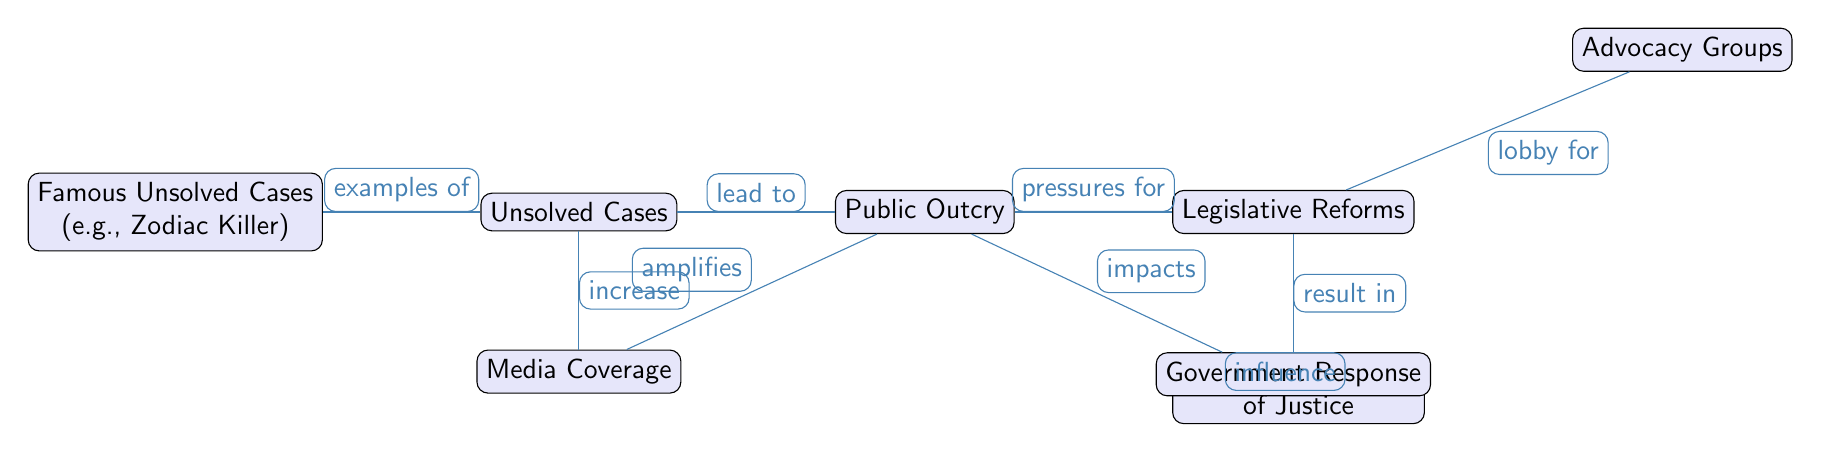What is the first node in the diagram? The first node in the diagram is labeled "Unsolved Cases," as it is positioned at the topmost part of the flow.
Answer: Unsolved Cases How many nodes are present in the diagram? By counting each of the distinct labeled boxes in the diagram, we find there are a total of eight nodes, including "Unsolved Cases" and "Legislative Reforms."
Answer: 8 What does "Public Outcry" lead to? The diagram shows that "Public Outcry" connects to and impacts "Societal Perceptions of Justice," as indicated by the directed edge between those two nodes.
Answer: Societal Perceptions of Justice Which node provides examples of "Unsolved Cases"? The node labeled "Famous Unsolved Cases (e.g., Zodiac Killer)" is connected to the "Unsolved Cases" node with an edge labeled "examples of." This indicates it offers specific examples of unsolved cases.
Answer: Famous Unsolved Cases (e.g., Zodiac Killer) What is the relationship between "Media Coverage" and "Public Outcry"? The edge shows that "Media Coverage" amplifies "Public Outcry," suggesting that increased media coverage leads to a greater public response or demand for justice.
Answer: amplifies What influences "Societal Perceptions of Justice"? The edge from "Government Response" to "Societal Perceptions of Justice" indicates that the actions of the government can influence how society perceives justice, especially in the context of unsolved cases.
Answer: Government Response What do "Advocacy Groups" do regarding "Legislative Reforms"? The edge labeled "lobby for" clearly indicates that "Advocacy Groups" actively work to influence or promote "Legislative Reforms."
Answer: lobby for How does "Legislative Reforms" impact "Government Response"? The diagram indicates that "Legislative Reforms" result in "Government Response," demonstrating a cause-and-effect relationship where reforms lead to specific governmental actions.
Answer: result in What effect does "Unsolved Cases" have on "Media Coverage"? The diagram delineates that "Unsolved Cases" increase "Media Coverage," implying that unresolved cases attract more media attention.
Answer: increase 